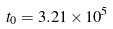Convert formula to latex. <formula><loc_0><loc_0><loc_500><loc_500>t _ { 0 } = 3 . 2 1 \times { 1 0 } ^ { 5 }</formula> 